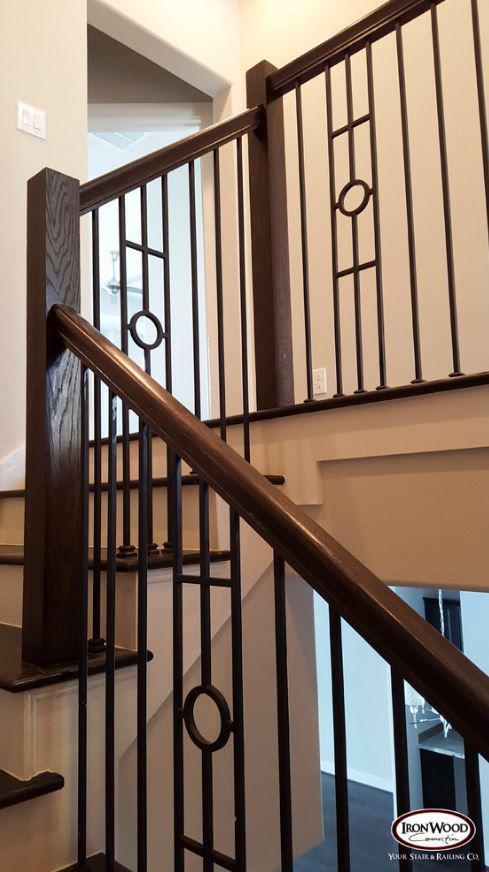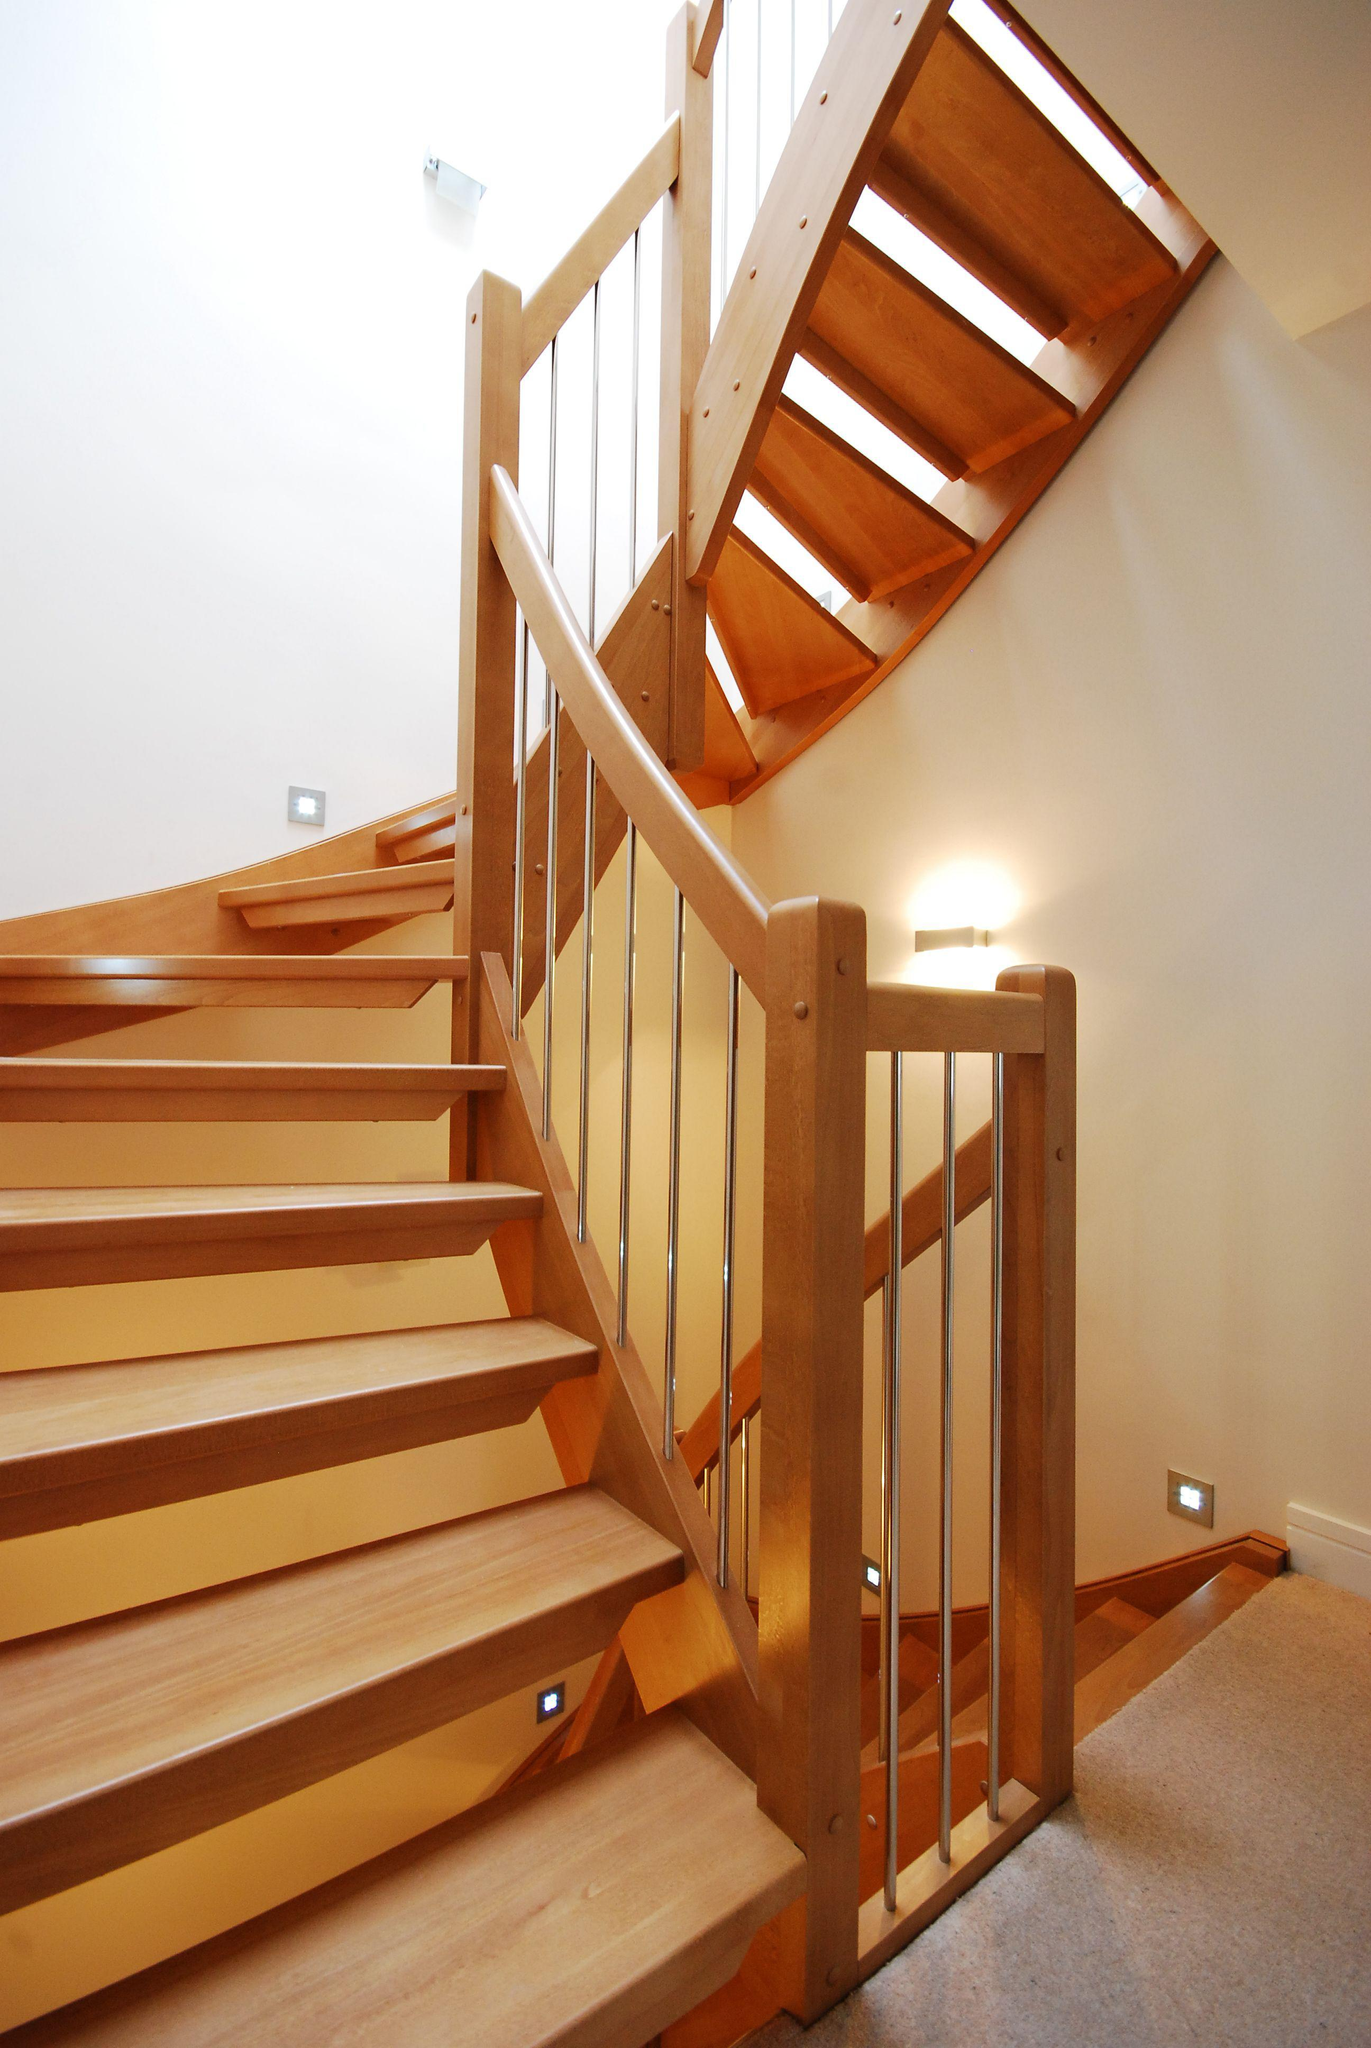The first image is the image on the left, the second image is the image on the right. Evaluate the accuracy of this statement regarding the images: "One of the railings is white.". Is it true? Answer yes or no. No. The first image is the image on the left, the second image is the image on the right. For the images shown, is this caption "One image features a staircase that takes a turn to the right and has dark rails with vertical wrought iron bars accented with circle shapes." true? Answer yes or no. Yes. 